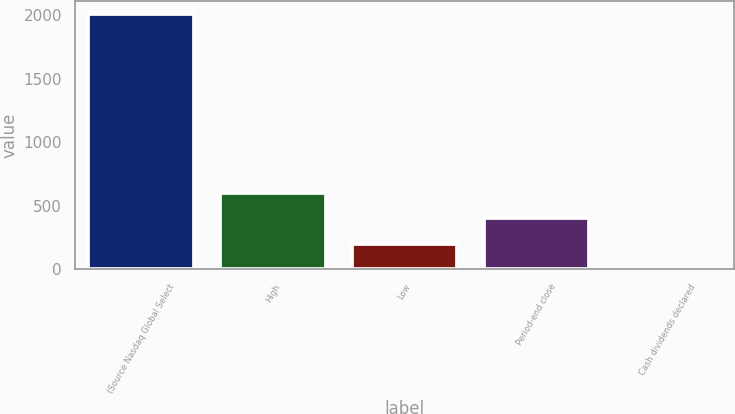Convert chart to OTSL. <chart><loc_0><loc_0><loc_500><loc_500><bar_chart><fcel>(Source Nasdaq Global Select<fcel>High<fcel>Low<fcel>Period-end close<fcel>Cash dividends declared<nl><fcel>2008<fcel>602.67<fcel>201.15<fcel>401.91<fcel>0.39<nl></chart> 